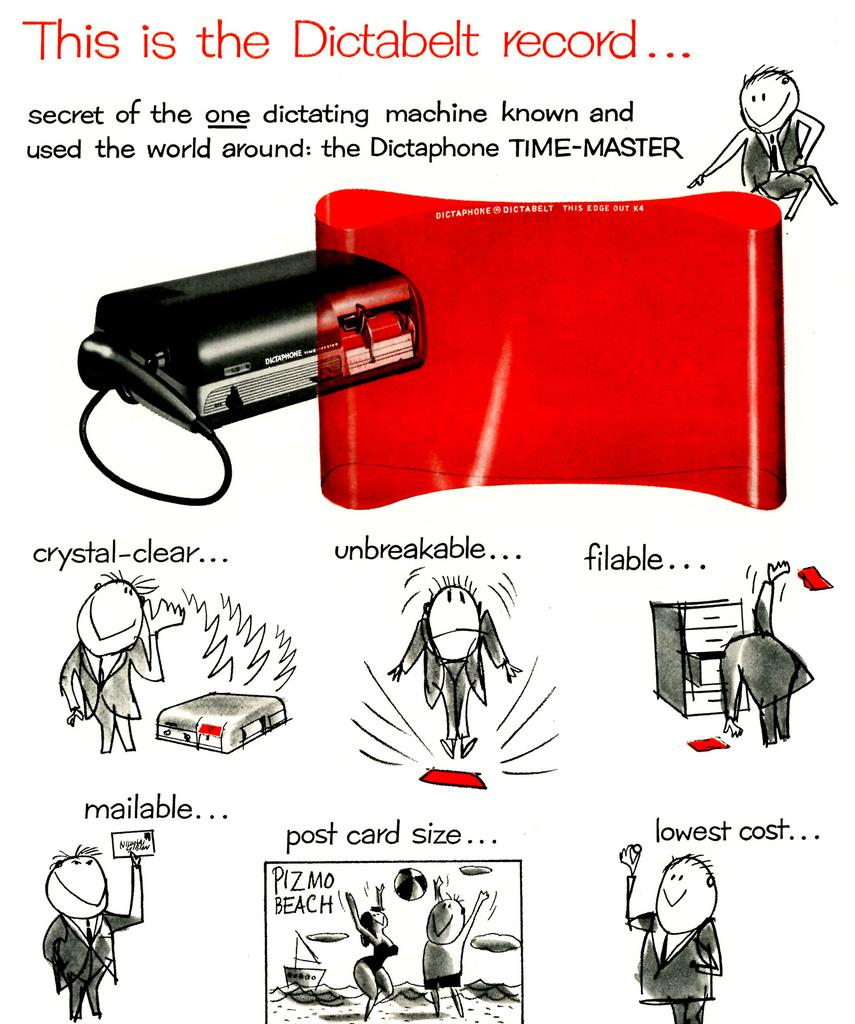<image>
Render a clear and concise summary of the photo. An advertisement for the Dictabelt record showing some of its features. 